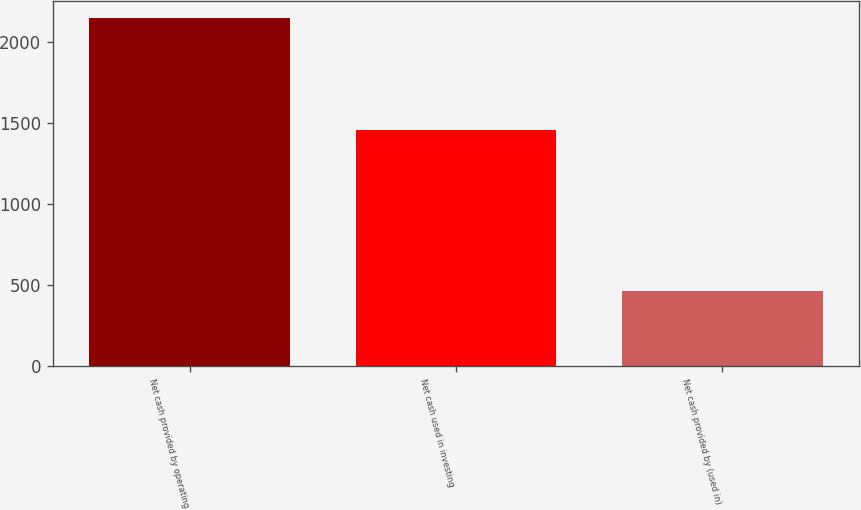<chart> <loc_0><loc_0><loc_500><loc_500><bar_chart><fcel>Net cash provided by operating<fcel>Net cash used in investing<fcel>Net cash provided by (used in)<nl><fcel>2143<fcel>1458<fcel>464<nl></chart> 